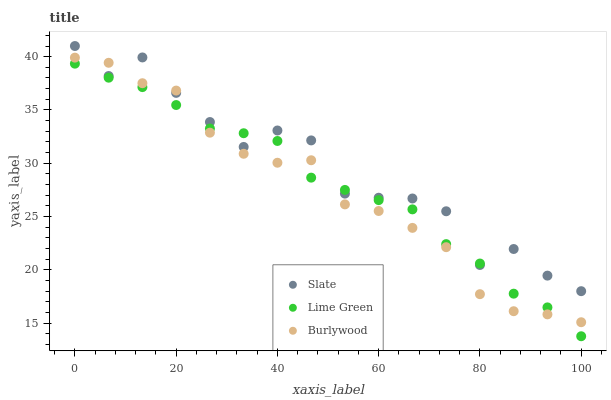Does Burlywood have the minimum area under the curve?
Answer yes or no. Yes. Does Slate have the maximum area under the curve?
Answer yes or no. Yes. Does Lime Green have the minimum area under the curve?
Answer yes or no. No. Does Lime Green have the maximum area under the curve?
Answer yes or no. No. Is Lime Green the smoothest?
Answer yes or no. Yes. Is Slate the roughest?
Answer yes or no. Yes. Is Slate the smoothest?
Answer yes or no. No. Is Lime Green the roughest?
Answer yes or no. No. Does Lime Green have the lowest value?
Answer yes or no. Yes. Does Slate have the lowest value?
Answer yes or no. No. Does Slate have the highest value?
Answer yes or no. Yes. Does Lime Green have the highest value?
Answer yes or no. No. Does Slate intersect Lime Green?
Answer yes or no. Yes. Is Slate less than Lime Green?
Answer yes or no. No. Is Slate greater than Lime Green?
Answer yes or no. No. 